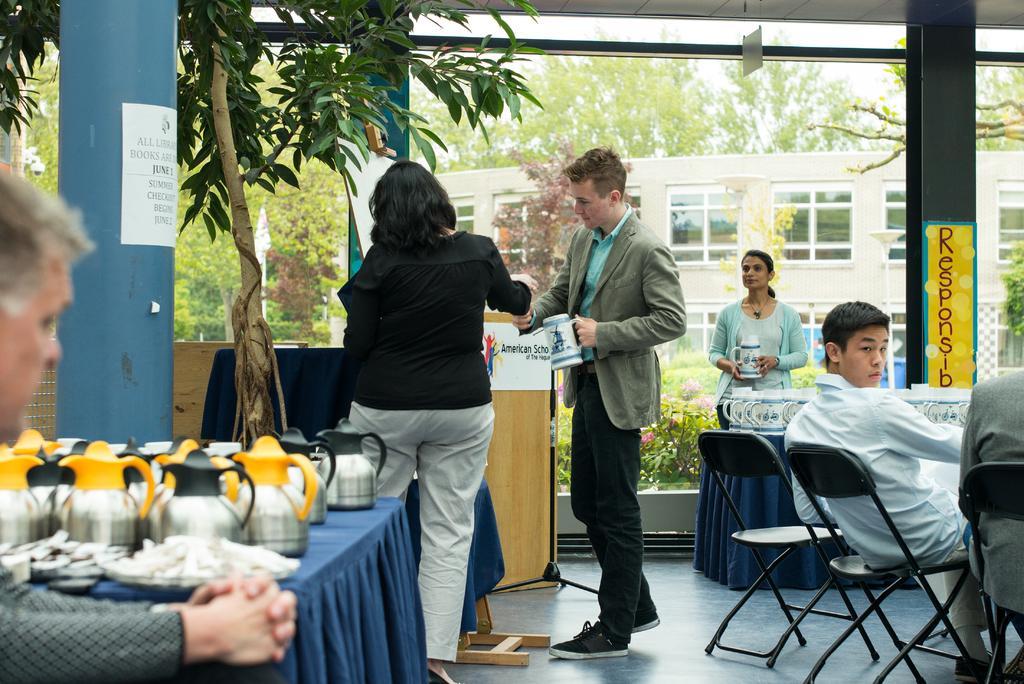In one or two sentences, can you explain what this image depicts? The picture is taken outside a building. In the middle one person is standing he is holding a mug. in front of him one lady is standing she is wearing a black top. Behind the lady there is table. On the table there are many kettles and some other stuffs. In the left side one man is sitting. On the right side two people are sitting on chairs. In front of them there is a table. On the table there are many jugs. behind the table a lady is standing. she is holding a jug. In the background there are trees ,building. the sky is clear. there is pillar in the left side on the pillar there is a sign board. 